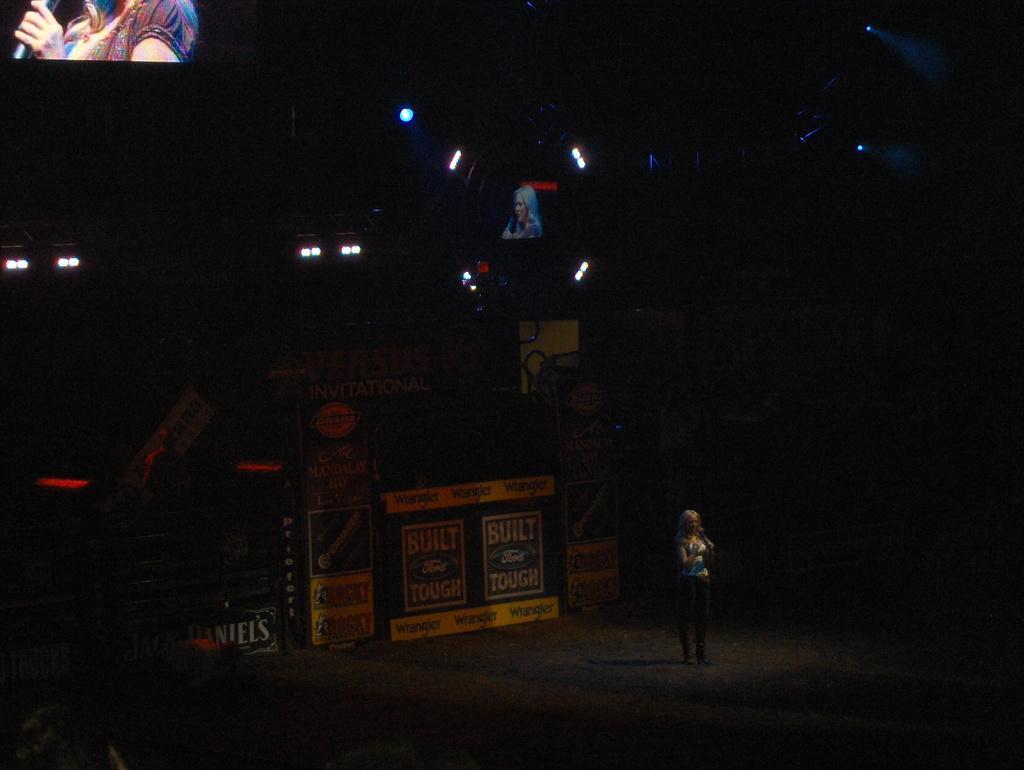Could you give a brief overview of what you see in this image? In the middle of the image there is a lady standing. Behind her there is a black background with a screen and lights. In the top left corner of the image there is a screen with an image in it.  